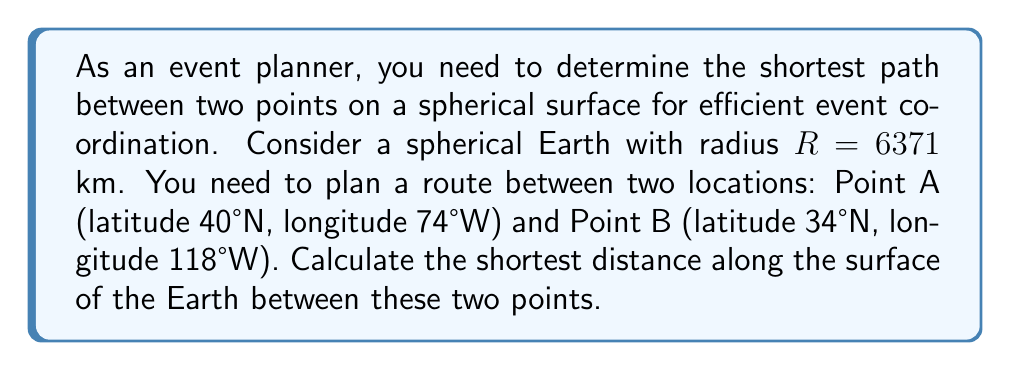Solve this math problem. To solve this problem, we'll use the concept of geodesics on a sphere, which are great circles. The shortest path between two points on a sphere is along the great circle that passes through both points. We'll use the spherical law of cosines to calculate this distance.

Step 1: Convert the latitudes and longitudes to radians.
$\phi_1 = 40° \cdot \frac{\pi}{180} = 0.6981$ radians
$\lambda_1 = -74° \cdot \frac{\pi}{180} = -1.2915$ radians
$\phi_2 = 34° \cdot \frac{\pi}{180} = 0.5934$ radians
$\lambda_2 = -118° \cdot \frac{\pi}{180} = -2.0594$ radians

Step 2: Calculate the central angle $\Delta\sigma$ using the spherical law of cosines:
$$\cos(\Delta\sigma) = \sin(\phi_1)\sin(\phi_2) + \cos(\phi_1)\cos(\phi_2)\cos(\lambda_2 - \lambda_1)$$

Step 3: Substitute the values:
$$\begin{align*}
\cos(\Delta\sigma) &= \sin(0.6981)\sin(0.5934) + \cos(0.6981)\cos(0.5934)\cos(-2.0594 - (-1.2915)) \\
&= 0.6428 \cdot 0.5591 + 0.7660 \cdot 0.8290 \cdot \cos(-0.7679) \\
&= 0.3594 + 0.6350 \cdot 0.7189 \\
&= 0.3594 + 0.4565 \\
&= 0.8159
\end{align*}$$

Step 4: Calculate $\Delta\sigma$:
$$\Delta\sigma = \arccos(0.8159) = 0.6088 \text{ radians}$$

Step 5: Calculate the distance $d$ along the great circle:
$$d = R \cdot \Delta\sigma = 6371 \text{ km} \cdot 0.6088 = 3878.5 \text{ km}$$

Therefore, the shortest distance along the surface of the Earth between the two points is approximately 3878.5 km.
Answer: The shortest distance between Point A (40°N, 74°W) and Point B (34°N, 118°W) along the surface of the Earth is approximately 3878.5 km. 